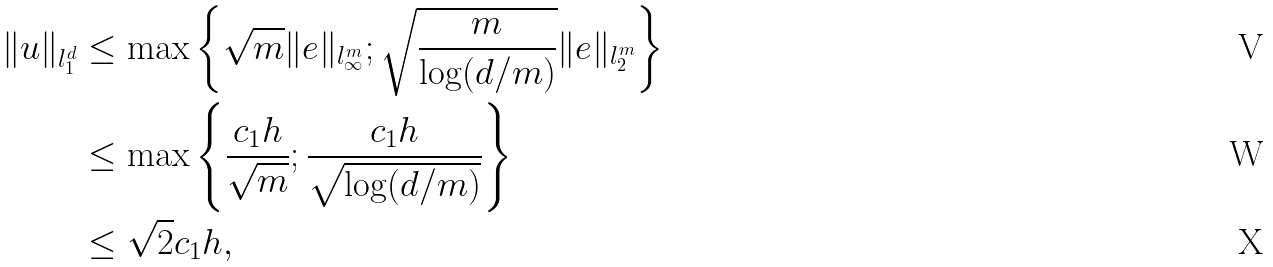<formula> <loc_0><loc_0><loc_500><loc_500>\| u \| _ { l _ { 1 } ^ { d } } & \leq \max \left \{ \sqrt { m } \| e \| _ { l _ { \infty } ^ { m } } ; \sqrt { \frac { m } { \log ( d / m ) } } \| e \| _ { l _ { 2 } ^ { m } } \right \} \\ & \leq \max \left \{ \frac { c _ { 1 } h } { \sqrt { m } } ; \frac { c _ { 1 } h } { \sqrt { \log ( d / m ) } } \right \} \\ & \leq \sqrt { 2 } c _ { 1 } h ,</formula> 